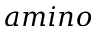<formula> <loc_0><loc_0><loc_500><loc_500>a \min o</formula> 